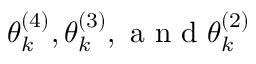Convert formula to latex. <formula><loc_0><loc_0><loc_500><loc_500>\theta _ { k } ^ { ( 4 ) } , \theta _ { k } ^ { ( 3 ) } , a n d \theta _ { k } ^ { ( 2 ) }</formula> 